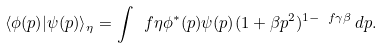Convert formula to latex. <formula><loc_0><loc_0><loc_500><loc_500>\langle \phi ( p ) | \psi ( p ) \rangle _ { \eta } = \int \ f { \eta \phi ^ { * } ( p ) \psi ( p ) } { ( 1 + \beta p ^ { 2 } ) ^ { 1 - \ f { \gamma } { \beta } } } \, d p .</formula> 